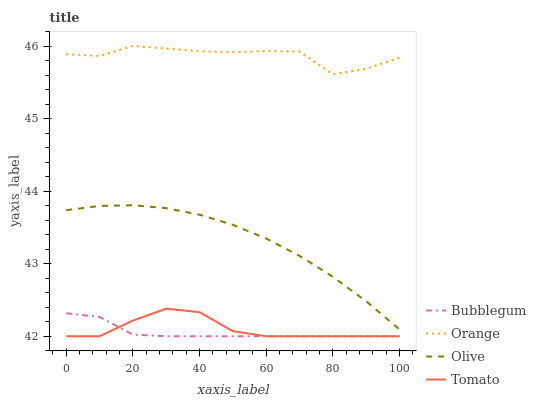Does Bubblegum have the minimum area under the curve?
Answer yes or no. Yes. Does Orange have the maximum area under the curve?
Answer yes or no. Yes. Does Olive have the minimum area under the curve?
Answer yes or no. No. Does Olive have the maximum area under the curve?
Answer yes or no. No. Is Bubblegum the smoothest?
Answer yes or no. Yes. Is Orange the roughest?
Answer yes or no. Yes. Is Olive the smoothest?
Answer yes or no. No. Is Olive the roughest?
Answer yes or no. No. Does Tomato have the lowest value?
Answer yes or no. Yes. Does Olive have the lowest value?
Answer yes or no. No. Does Orange have the highest value?
Answer yes or no. Yes. Does Olive have the highest value?
Answer yes or no. No. Is Tomato less than Orange?
Answer yes or no. Yes. Is Orange greater than Tomato?
Answer yes or no. Yes. Does Tomato intersect Bubblegum?
Answer yes or no. Yes. Is Tomato less than Bubblegum?
Answer yes or no. No. Is Tomato greater than Bubblegum?
Answer yes or no. No. Does Tomato intersect Orange?
Answer yes or no. No. 